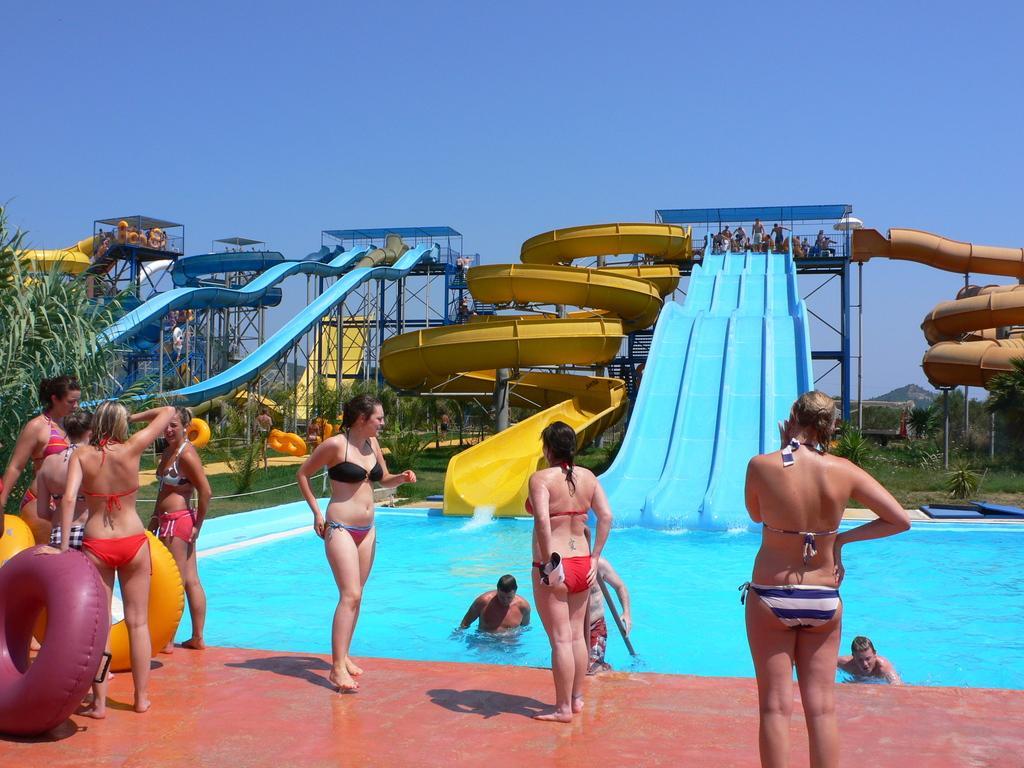How would you summarize this image in a sentence or two? In this picture there is a woman who is wearing black and blue dress. Here we can see another woman who is wearing red dress standing near to the swimming pool. On the left we can see group of persons who are standing with the tubes. On the right we can see group of persons who are standing above the shed and some peoples are doing sliding. On the left we can see plants. On the top there is a sky. Here we can see some people doing swimming in the swimming pool. On the background we can see mountain. 